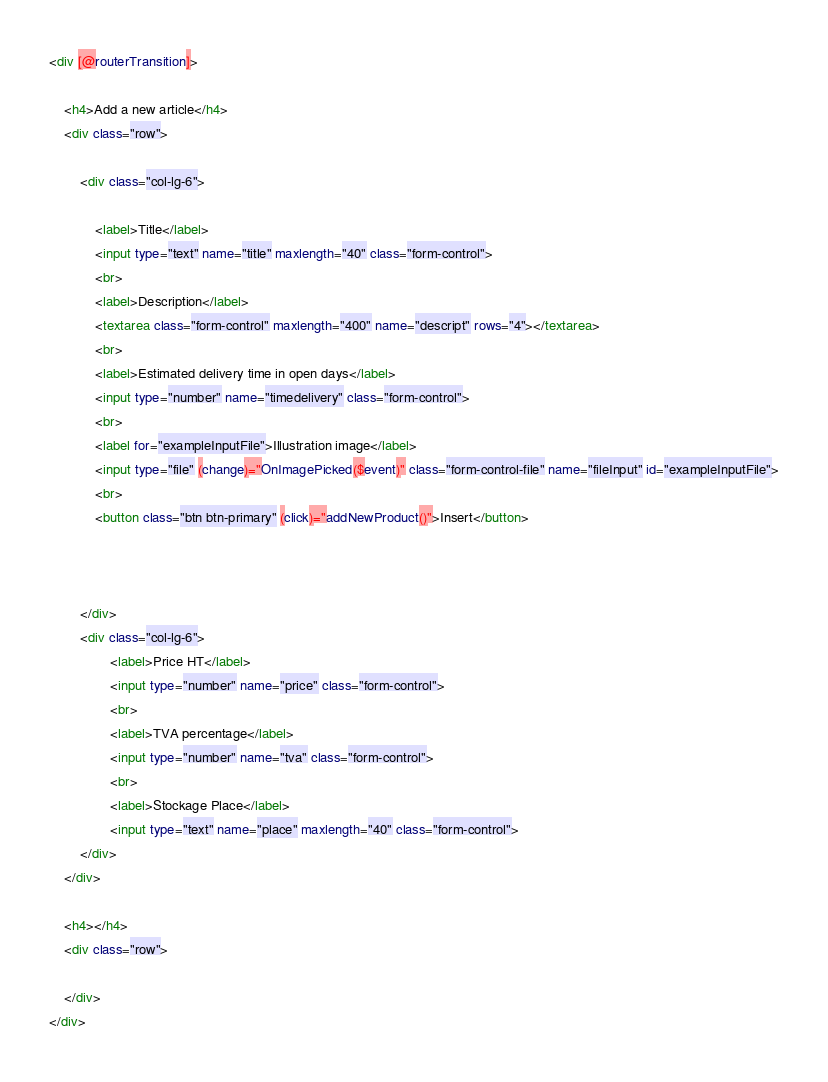Convert code to text. <code><loc_0><loc_0><loc_500><loc_500><_HTML_><div [@routerTransition]>
    
    <h4>Add a new article</h4>
    <div class="row">
      
        <div class="col-lg-6">

            <label>Title</label>
            <input type="text" name="title" maxlength="40" class="form-control">
            <br>
            <label>Description</label>
            <textarea class="form-control" maxlength="400" name="descript" rows="4"></textarea>
            <br>
            <label>Estimated delivery time in open days</label>
            <input type="number" name="timedelivery" class="form-control">
            <br>
            <label for="exampleInputFile">Illustration image</label>
            <input type="file" (change)="OnImagePicked($event)" class="form-control-file" name="fileInput" id="exampleInputFile">
            <br>
            <button class="btn btn-primary" (click)="addNewProduct()">Insert</button>
                

        
        </div>
        <div class="col-lg-6">
                <label>Price HT</label>
                <input type="number" name="price" class="form-control">
                <br>
                <label>TVA percentage</label>
                <input type="number" name="tva" class="form-control">
                <br>
                <label>Stockage Place</label>
                <input type="text" name="place" maxlength="40" class="form-control">
        </div>
    </div>

    <h4></h4>
    <div class="row">

    </div>
</div>
</code> 